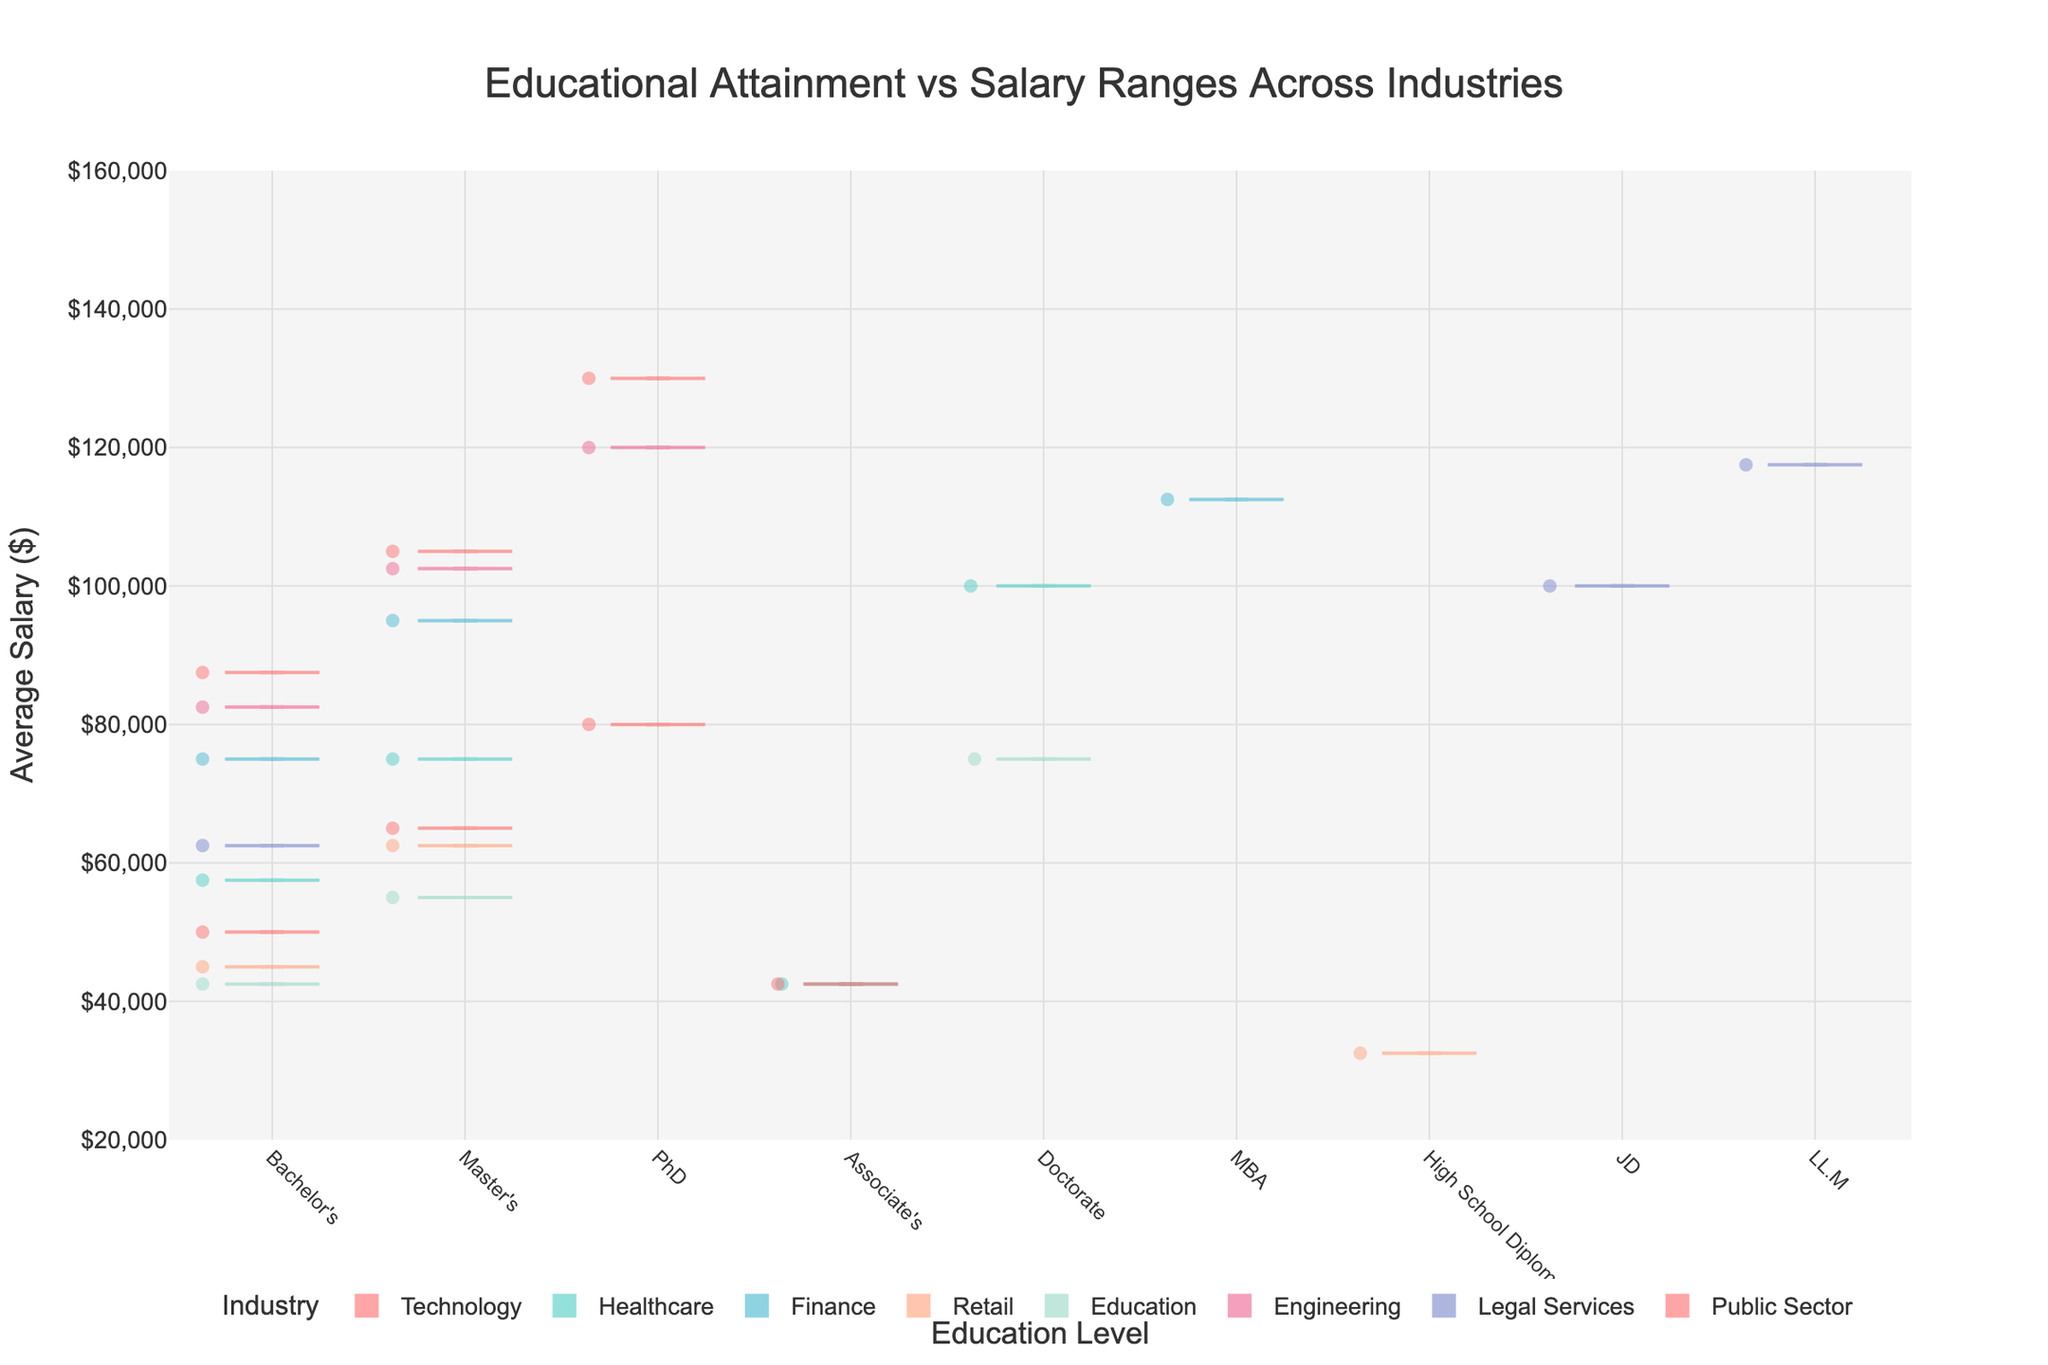What is the title of the chart? The title of the chart is displayed prominently at the top, describing what the chart represents. It reads "Educational Attainment vs Salary Ranges Across Industries".
Answer: Educational Attainment vs Salary Ranges Across Industries Which industry has the highest average salary for those with a Bachelor's degree? By examining the averages on the y-axis and identifying the highest values among Bachelor's degree holders, it can be observed that the Technology industry shows the highest average salary.
Answer: Technology How does the average salary for a Master's degree in Engineering compare to a PhD in Public Sector? First, locate the average salaries for a Master's degree in Engineering and a PhD in Public Sector on the y-axis. Then, compare the two values. The Master's degree in Engineering typically has around $102,500 while a PhD in Public Sector shows approximately $80,000, making the Engineering Master's higher.
Answer: The Master's in Engineering is higher Which education level in the Retail industry has the largest spread in salary ranges? For each education level in Retail, observe the width of the violin indicating the salary spread from the minimum to the maximum. The Bachelor's degree shows a spread of $35,000 - $55,000, the widest among the choices.
Answer: Bachelor's degree What is the median salary for a PhD in Technology? The box plot overlay within the violin plot for PhD in Technology shows the median line. The median salary is around $130,000, which is the line in the middle of the box.
Answer: $130,000 Across all industries, which has the most significant difference between the minimum and maximum average salaries? Looking at each industry, find the minimum and maximum average salaries and calculate the differences. The Technology industry ranges from $87,500 (Bachelor's) to $130,000 (PhD), a difference of $42,500. This calculation reveals Technology has the most significant difference.
Answer: Technology What can you infer about the variability in salaries for JDs in Legal Services compared to MBAs in Finance? By observing the violin plots' width and the box plots' heights for JDs in Legal Services and MBAs in Finance, JDs display a broader spread and variability while MBAs in Finance show less spread and more concentration. The larger spread indicates higher variability for JDs in Legal Services.
Answer: JDs in Legal Services have higher variability How do the averages for Bachelor's degrees in Healthcare compare to those in Education? Compare the central points on the violin plots for Bachelor's degrees in Healthcare and Education. Healthcare averages about $57,500, while Education averages around $42,500. Hence, Healthcare is higher.
Answer: Healthcare is higher What is the general trend observed between educational attainment and salary across different industries? There is a clear trend in the chart that higher educational attainment generally correlates with higher average salaries, as indicated by the upward shift in the violins and box plots with increasing education levels.
Answer: Higher education generally leads to higher salaries Which industry shows the smallest difference between the average salaries for Associate's and PhDs? By comparing the difference across industries with both Associate's and PhDs, the Public Sector shows the smallest difference between the average salaries for these two education levels, approximately $52,500 to $80,000.
Answer: Public Sector 